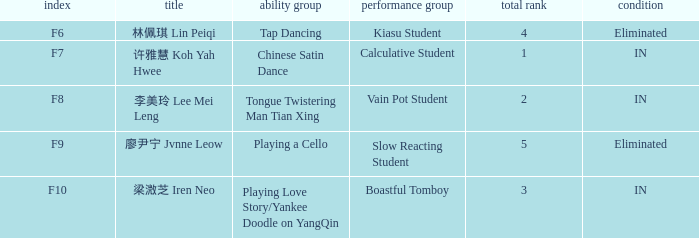For the event with index f7, what is the status? IN. 